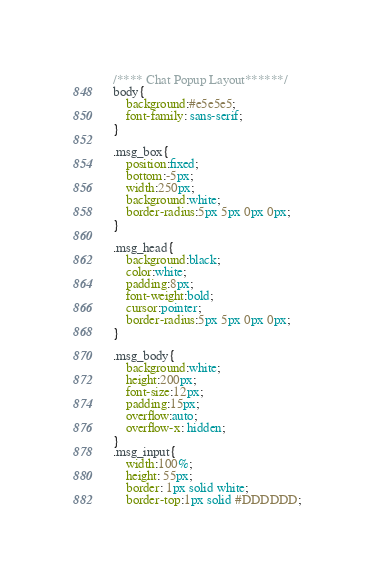Convert code to text. <code><loc_0><loc_0><loc_500><loc_500><_CSS_>/**** Chat Popup Layout******/
body{
    background:#e5e5e5;
    font-family: sans-serif;
}

.msg_box{
    position:fixed;
    bottom:-5px;
    width:250px;
    background:white;
    border-radius:5px 5px 0px 0px;
}

.msg_head{
    background:black;
    color:white;
    padding:8px;
    font-weight:bold;
    cursor:pointer;
    border-radius:5px 5px 0px 0px;
}

.msg_body{
    background:white;
    height:200px;
    font-size:12px;
    padding:15px;
    overflow:auto;
    overflow-x: hidden;
}
.msg_input{
    width:100%;
    height: 55px;
    border: 1px solid white;
    border-top:1px solid #DDDDDD;</code> 